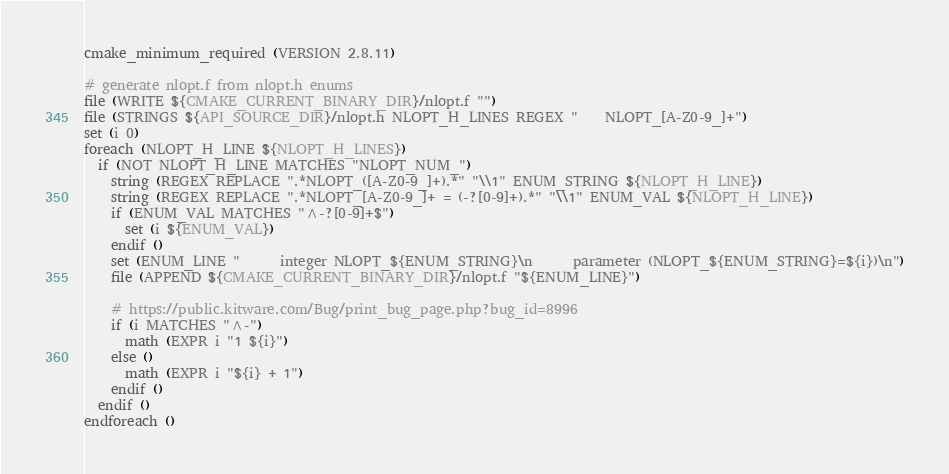Convert code to text. <code><loc_0><loc_0><loc_500><loc_500><_CMake_>cmake_minimum_required (VERSION 2.8.11)

# generate nlopt.f from nlopt.h enums
file (WRITE ${CMAKE_CURRENT_BINARY_DIR}/nlopt.f "")
file (STRINGS ${API_SOURCE_DIR}/nlopt.h NLOPT_H_LINES REGEX "    NLOPT_[A-Z0-9_]+")
set (i 0)
foreach (NLOPT_H_LINE ${NLOPT_H_LINES})
  if (NOT NLOPT_H_LINE MATCHES "NLOPT_NUM_")
    string (REGEX REPLACE ".*NLOPT_([A-Z0-9_]+).*" "\\1" ENUM_STRING ${NLOPT_H_LINE})
    string (REGEX REPLACE ".*NLOPT_[A-Z0-9_]+ = (-?[0-9]+).*" "\\1" ENUM_VAL ${NLOPT_H_LINE})
    if (ENUM_VAL MATCHES "^-?[0-9]+$")
      set (i ${ENUM_VAL})
    endif ()
    set (ENUM_LINE "      integer NLOPT_${ENUM_STRING}\n      parameter (NLOPT_${ENUM_STRING}=${i})\n")
    file (APPEND ${CMAKE_CURRENT_BINARY_DIR}/nlopt.f "${ENUM_LINE}")

    # https://public.kitware.com/Bug/print_bug_page.php?bug_id=8996
    if (i MATCHES "^-")
      math (EXPR i "1 ${i}")
    else ()
      math (EXPR i "${i} + 1")
    endif ()
  endif ()
endforeach ()
</code> 